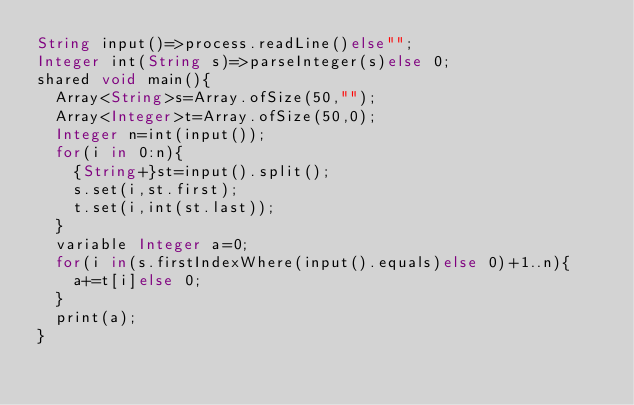<code> <loc_0><loc_0><loc_500><loc_500><_Ceylon_>String input()=>process.readLine()else""; 
Integer int(String s)=>parseInteger(s)else 0;
shared void main(){
  Array<String>s=Array.ofSize(50,"");
  Array<Integer>t=Array.ofSize(50,0);
  Integer n=int(input());
  for(i in 0:n){
    {String+}st=input().split();
    s.set(i,st.first);
    t.set(i,int(st.last));
  }
  variable Integer a=0;
  for(i in(s.firstIndexWhere(input().equals)else 0)+1..n){
    a+=t[i]else 0;
  }
  print(a);
}
</code> 